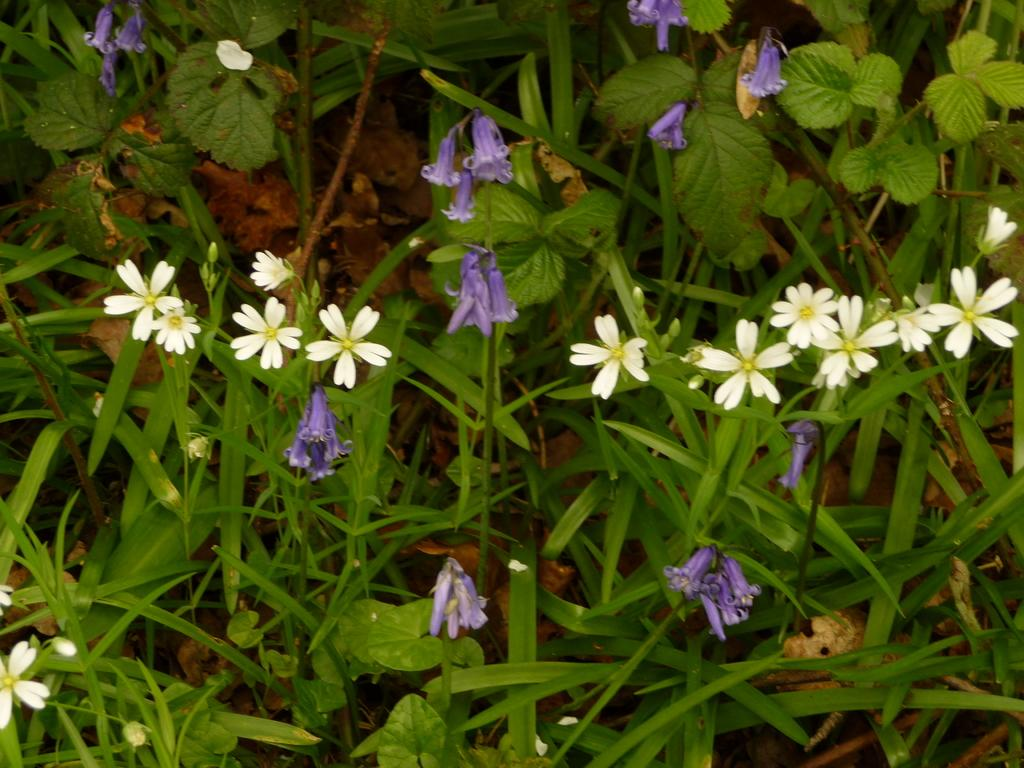What type of plants are in the picture? There are flower plants in the picture. What colors are the flowers? The flowers are white and purple in color. How many boats are visible in the picture? There are no boats present in the picture; it features flower plants with white and purple flowers. 